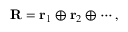<formula> <loc_0><loc_0><loc_500><loc_500>{ R } = { r } _ { 1 } \oplus { r } _ { 2 } \oplus \cdots ,</formula> 